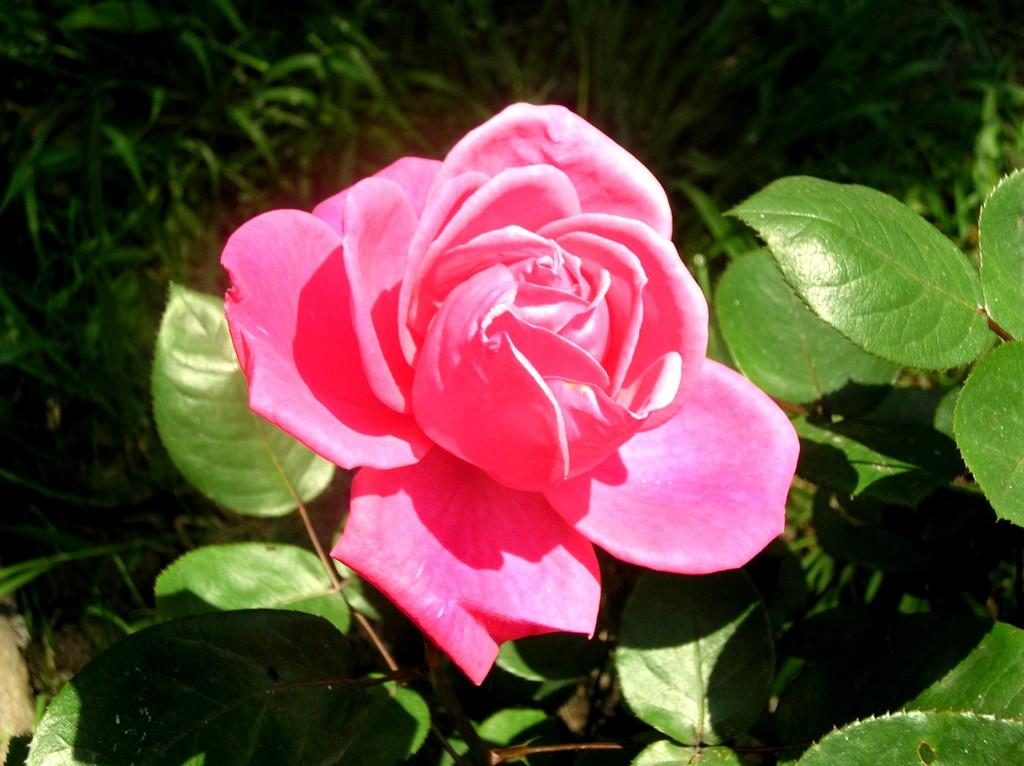What type of flower is in the image? There is a rose in the image. What other plant life is present in the image? There are plants in the image. Can you describe the background of the image? The background of the image is blurred. Where is the crown placed in the image? There is no crown present in the image. What type of club can be seen in the image? There is no club present in the image. 